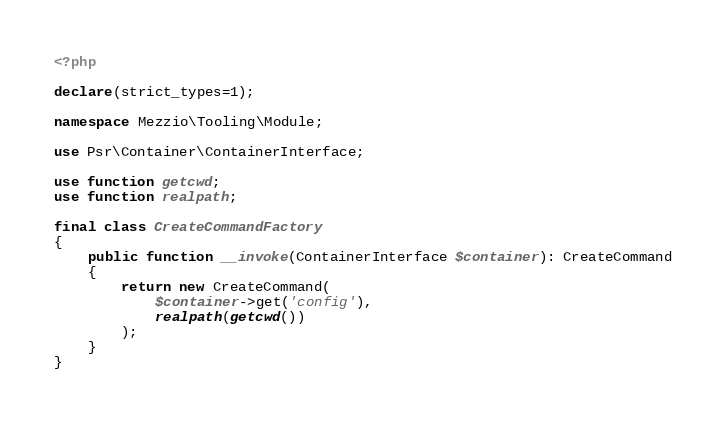<code> <loc_0><loc_0><loc_500><loc_500><_PHP_><?php

declare(strict_types=1);

namespace Mezzio\Tooling\Module;

use Psr\Container\ContainerInterface;

use function getcwd;
use function realpath;

final class CreateCommandFactory
{
    public function __invoke(ContainerInterface $container): CreateCommand
    {
        return new CreateCommand(
            $container->get('config'),
            realpath(getcwd())
        );
    }
}
</code> 